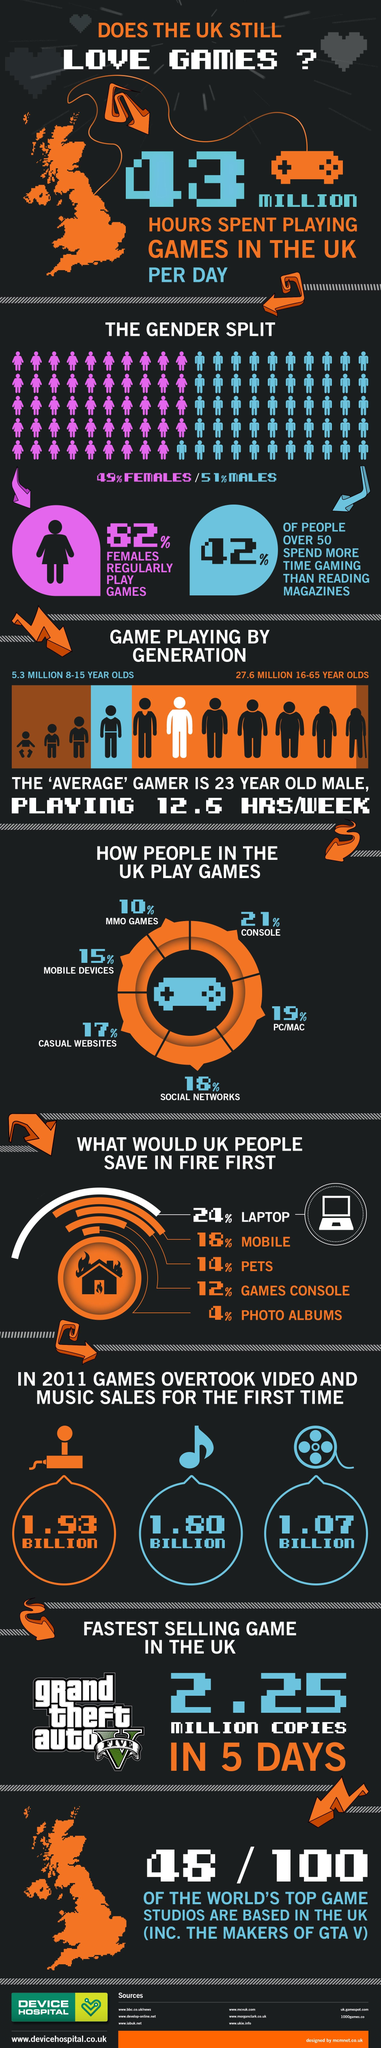Give some essential details in this illustration. In 2011, it was found that games were the most popular among the three options, namely games, music, and video. I declare that the least used medium to play games is MMO games. The second most commonly used medium for playing games is PCs and Macs. 